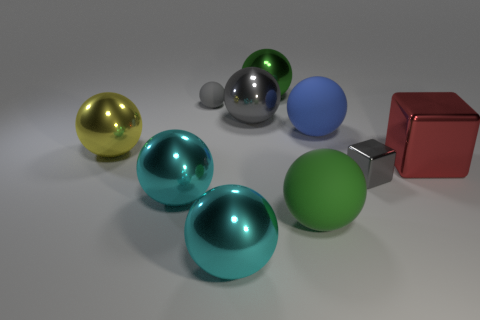There is a gray object that is the same size as the blue rubber object; what is it made of?
Keep it short and to the point. Metal. Are there any rubber objects that have the same color as the small metal block?
Give a very brief answer. Yes. There is a big metal thing that is right of the large gray metal thing and in front of the gray rubber thing; what is its shape?
Give a very brief answer. Cube. What number of small cubes are the same material as the large blue object?
Your response must be concise. 0. Are there fewer large spheres on the left side of the big gray thing than green things to the right of the big green shiny ball?
Your answer should be compact. No. What is the material of the small thing on the left side of the big rubber thing that is behind the big cyan object that is left of the gray rubber sphere?
Offer a very short reply. Rubber. There is a metallic ball that is to the left of the big gray object and behind the red object; what is its size?
Provide a succinct answer. Large. What number of cubes are either small things or large green things?
Provide a short and direct response. 1. What is the color of the cube that is the same size as the yellow thing?
Make the answer very short. Red. Are there any other things that are the same shape as the red thing?
Provide a succinct answer. Yes. 